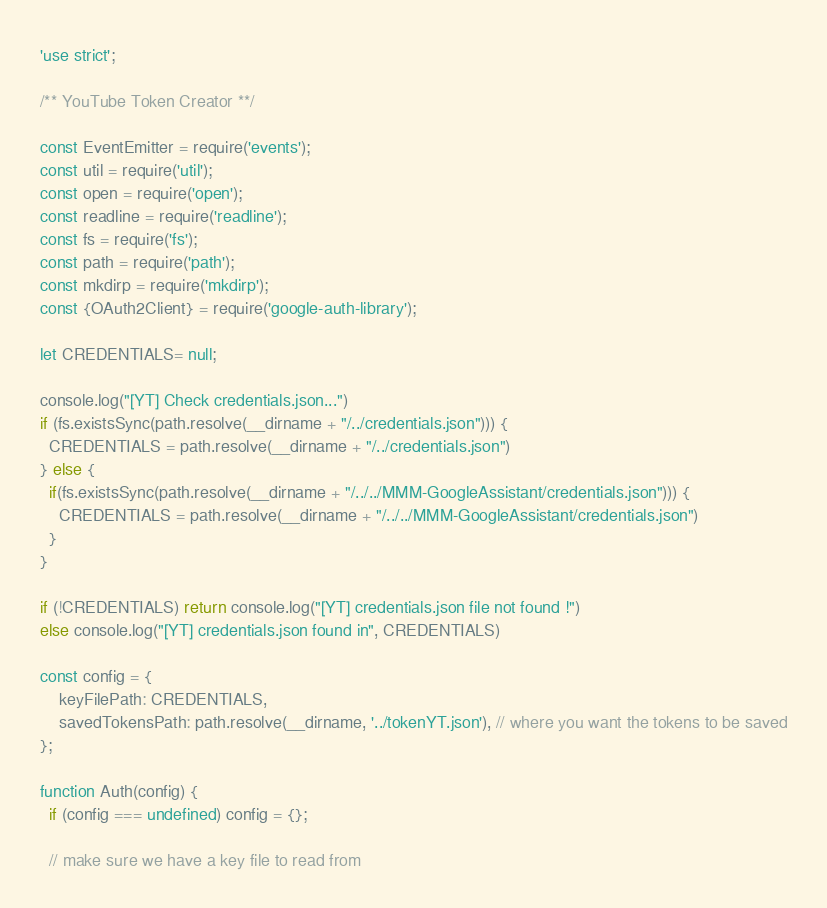<code> <loc_0><loc_0><loc_500><loc_500><_JavaScript_>'use strict';

/** YouTube Token Creator **/

const EventEmitter = require('events');
const util = require('util');
const open = require('open');
const readline = require('readline');
const fs = require('fs');
const path = require('path');
const mkdirp = require('mkdirp');
const {OAuth2Client} = require('google-auth-library');

let CREDENTIALS= null;

console.log("[YT] Check credentials.json...")
if (fs.existsSync(path.resolve(__dirname + "/../credentials.json"))) {
  CREDENTIALS = path.resolve(__dirname + "/../credentials.json")
} else {
  if(fs.existsSync(path.resolve(__dirname + "/../../MMM-GoogleAssistant/credentials.json"))) {
    CREDENTIALS = path.resolve(__dirname + "/../../MMM-GoogleAssistant/credentials.json")
  }
}

if (!CREDENTIALS) return console.log("[YT] credentials.json file not found !")
else console.log("[YT] credentials.json found in", CREDENTIALS)

const config = {
    keyFilePath: CREDENTIALS,
    savedTokensPath: path.resolve(__dirname, '../tokenYT.json'), // where you want the tokens to be saved
};

function Auth(config) {
  if (config === undefined) config = {};

  // make sure we have a key file to read from</code> 